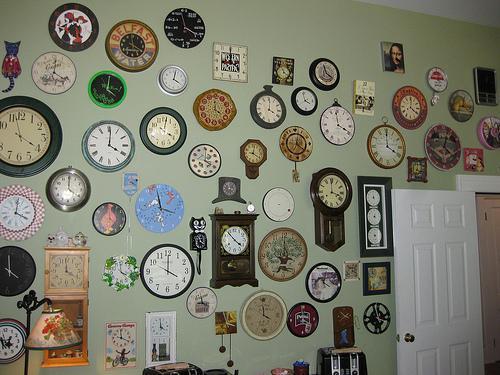How many doors are in this picture?
Give a very brief answer. 1. How many lamps are in the room?
Give a very brief answer. 1. 